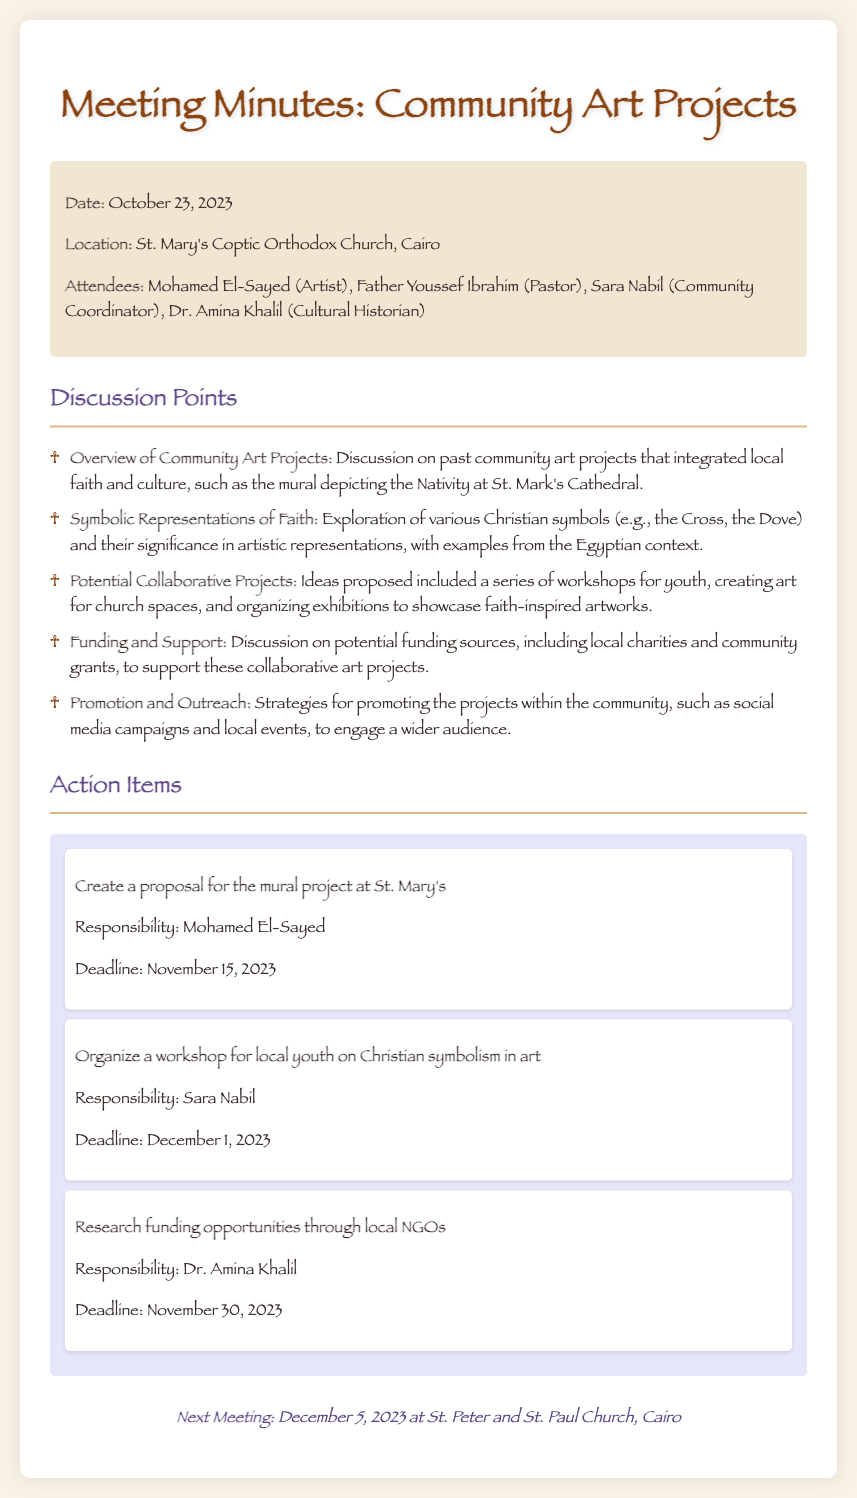What is the date of the meeting? The date is clearly stated in the document under the info section.
Answer: October 23, 2023 Who is responsible for creating a proposal for the mural project? This individual is mentioned in the action items section of the document.
Answer: Mohamed El-Sayed What location hosted the meeting? The location is specified in the info section at the beginning of the document.
Answer: St. Mary's Coptic Orthodox Church, Cairo What is the deadline for researching funding opportunities? The deadline is indicated in the action items section for the respective task.
Answer: November 30, 2023 What is one symbol of faith discussed in the meeting? This information can be found in the discussion points related to symbolic representations.
Answer: Cross How many attendees were present at the meeting? The number can be inferred from the list of attendees in the info section.
Answer: Four When is the next meeting scheduled? The date for the next meeting is listed at the end of the document.
Answer: December 5, 2023 What type of projects were proposed for collaboration? The proposals are outlined in the discussion points of the document.
Answer: Workshops for youth Which attendee is responsible for organizing a youth workshop? The responsible person is stated in the action items section of the document.
Answer: Sara Nabil 